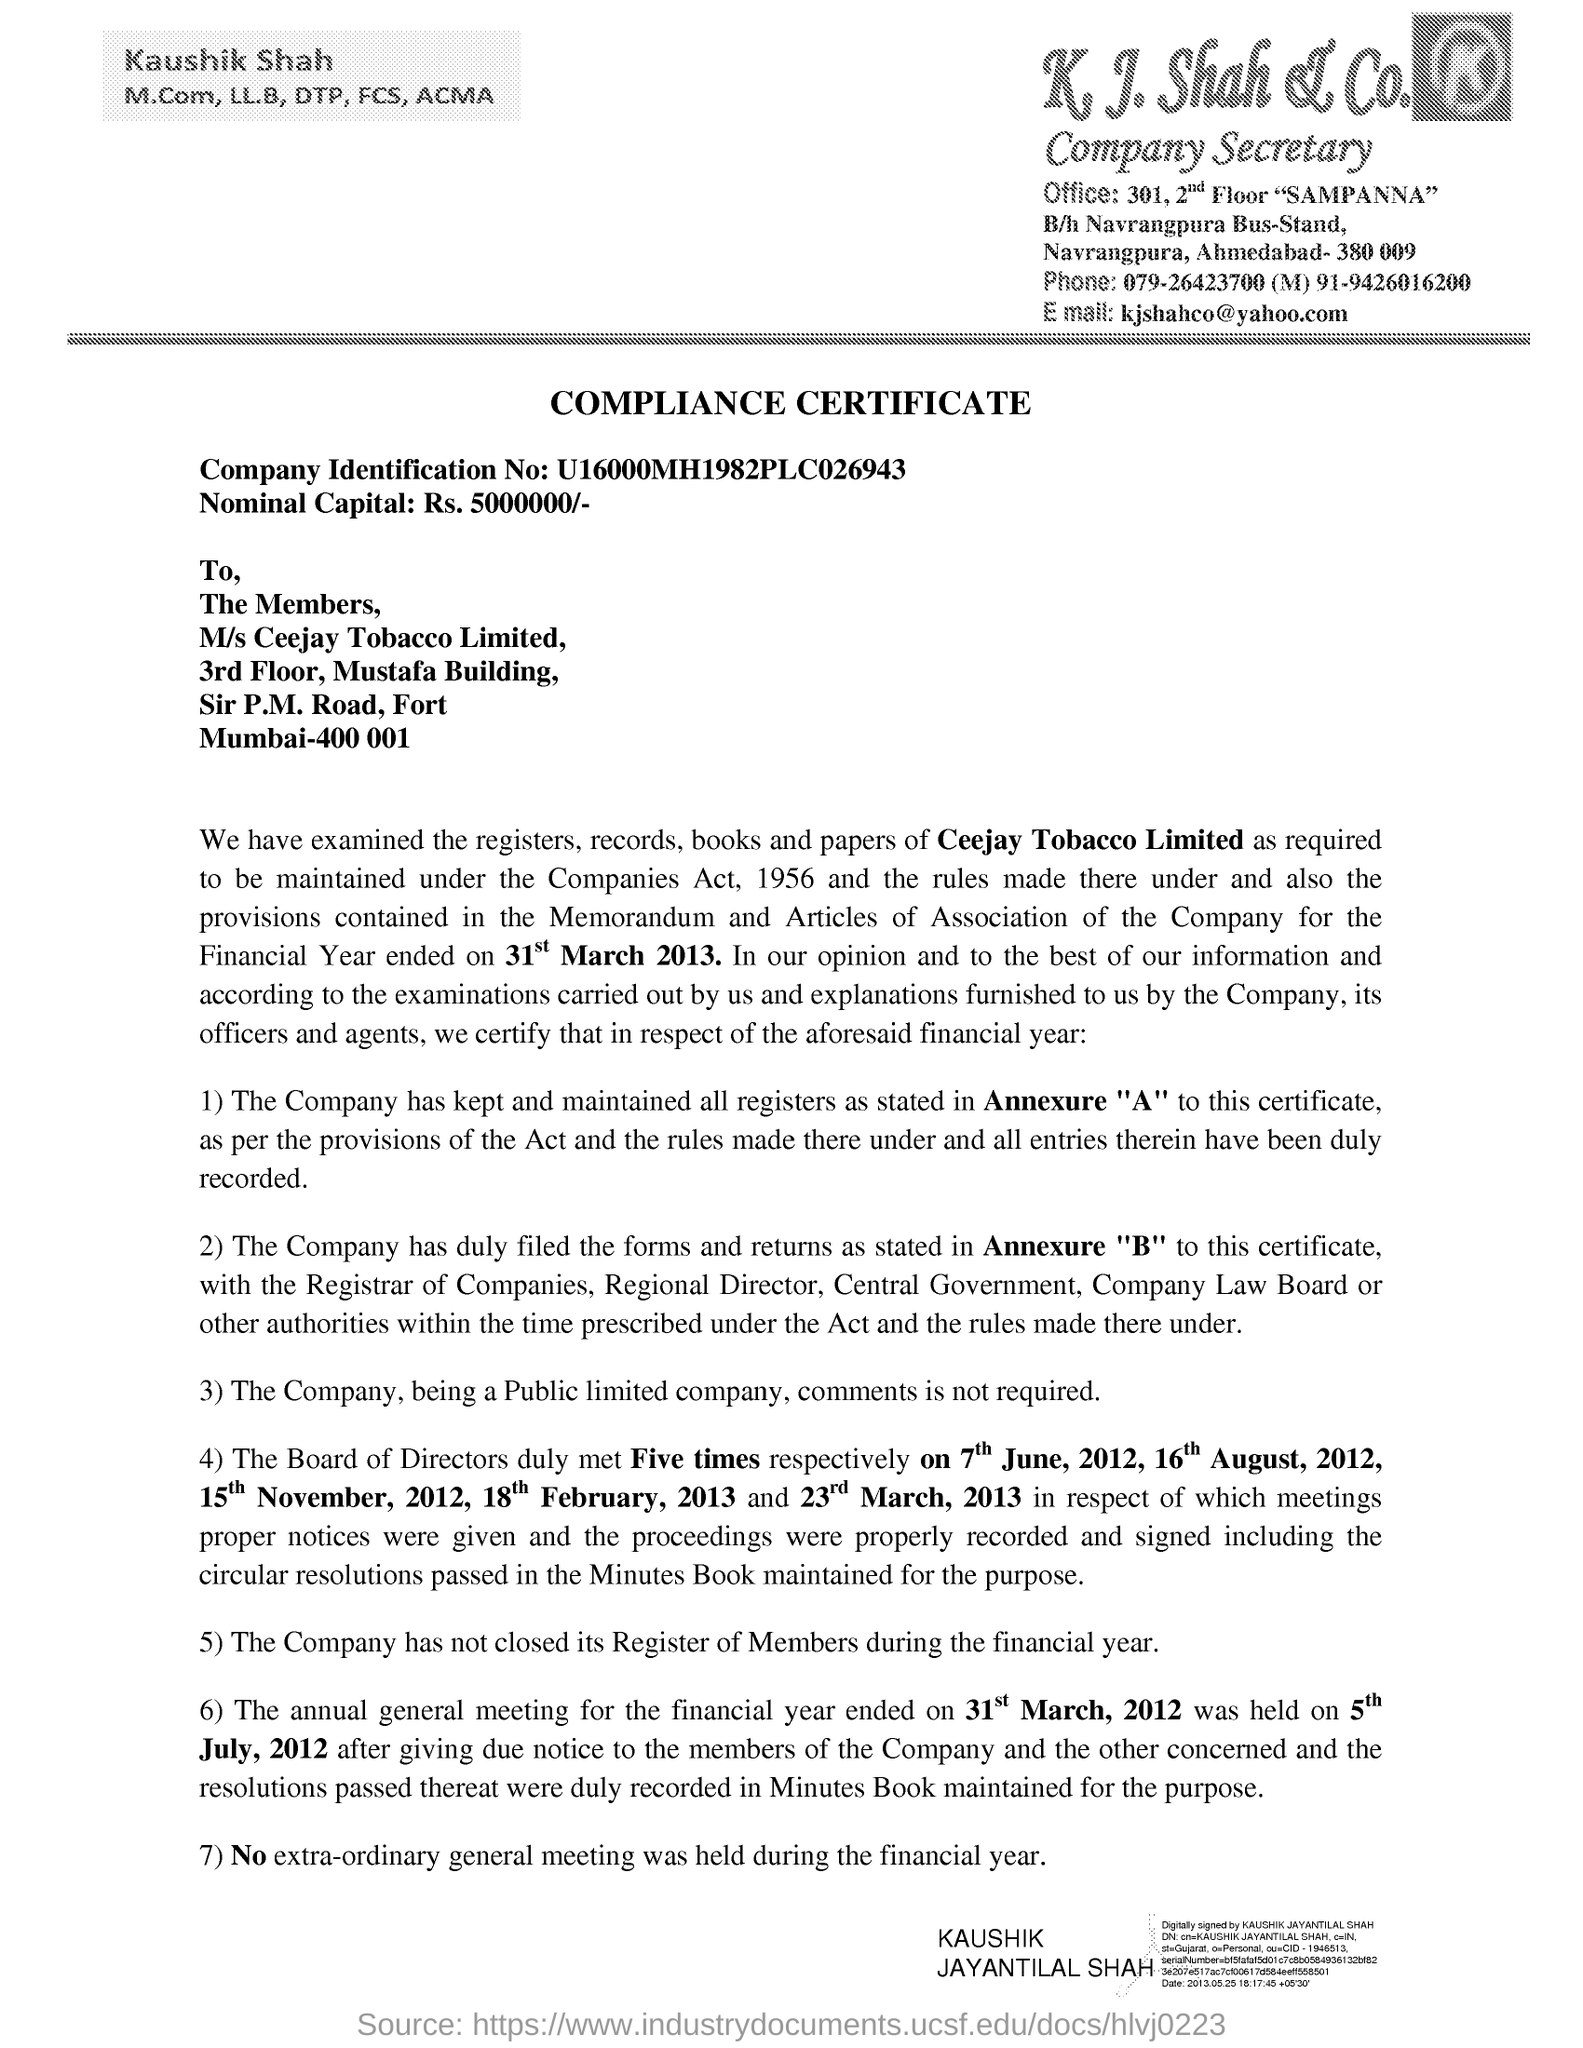Give some essential details in this illustration. This is a compliance certificate. The nominal capital mentioned in the document is 50,000,000/-. The header of the document mentions K. J. Shah & Co. as the company mentioned in the header of the document. The company identification number mentioned in the document is u16000mh1982plc026943. 